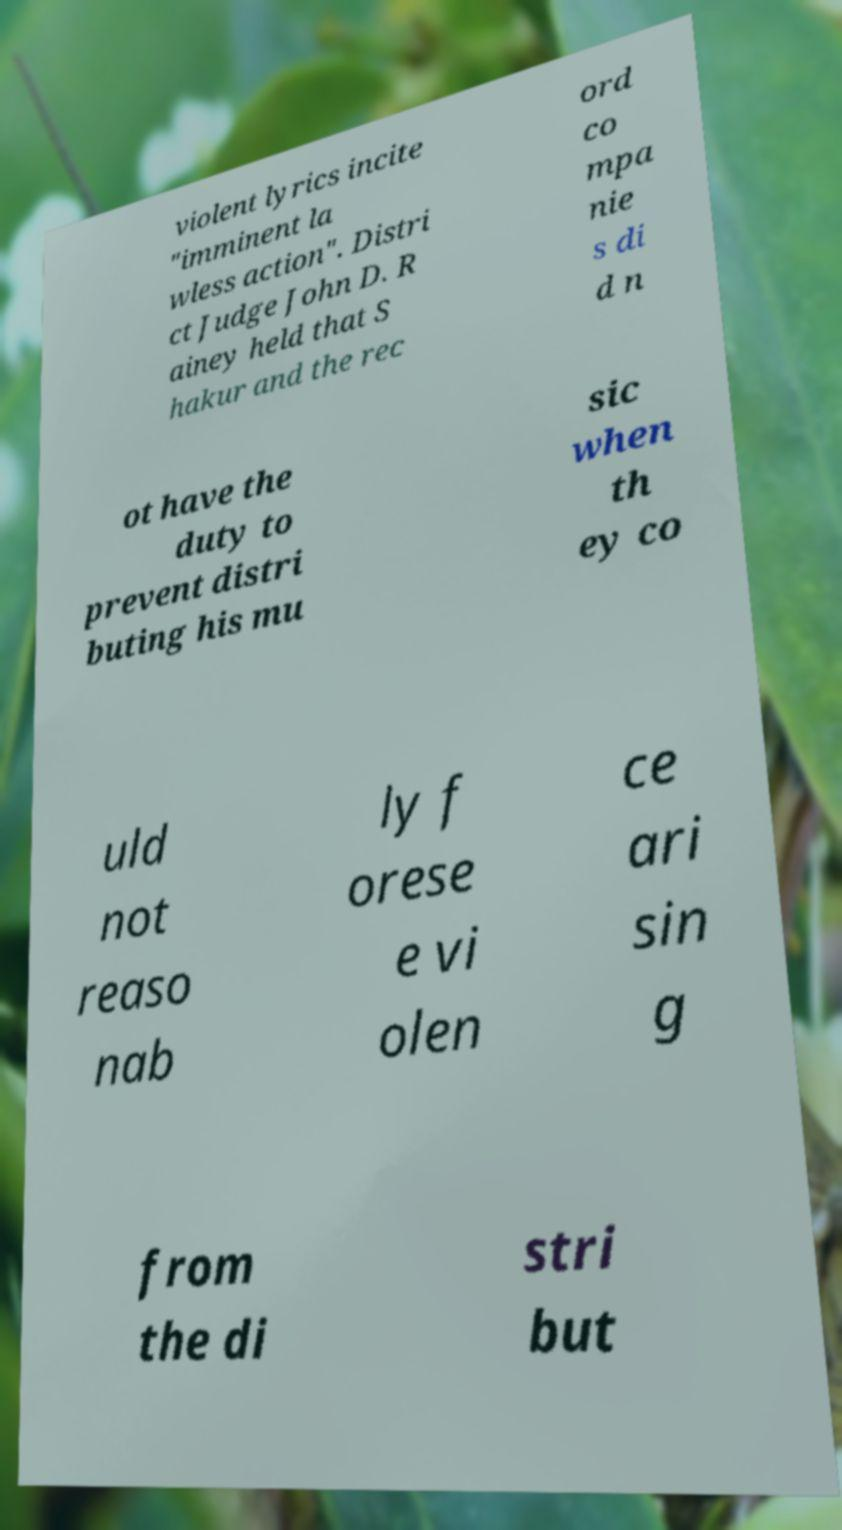Could you extract and type out the text from this image? violent lyrics incite "imminent la wless action". Distri ct Judge John D. R ainey held that S hakur and the rec ord co mpa nie s di d n ot have the duty to prevent distri buting his mu sic when th ey co uld not reaso nab ly f orese e vi olen ce ari sin g from the di stri but 